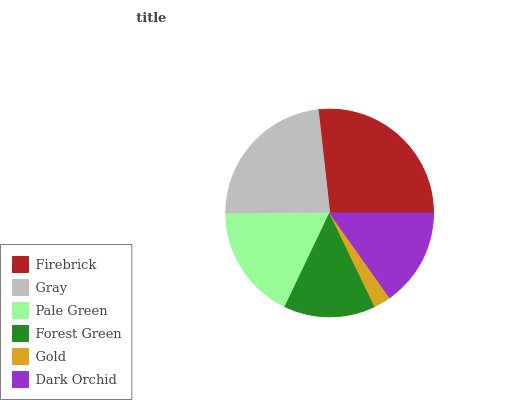Is Gold the minimum?
Answer yes or no. Yes. Is Firebrick the maximum?
Answer yes or no. Yes. Is Gray the minimum?
Answer yes or no. No. Is Gray the maximum?
Answer yes or no. No. Is Firebrick greater than Gray?
Answer yes or no. Yes. Is Gray less than Firebrick?
Answer yes or no. Yes. Is Gray greater than Firebrick?
Answer yes or no. No. Is Firebrick less than Gray?
Answer yes or no. No. Is Pale Green the high median?
Answer yes or no. Yes. Is Dark Orchid the low median?
Answer yes or no. Yes. Is Forest Green the high median?
Answer yes or no. No. Is Gray the low median?
Answer yes or no. No. 